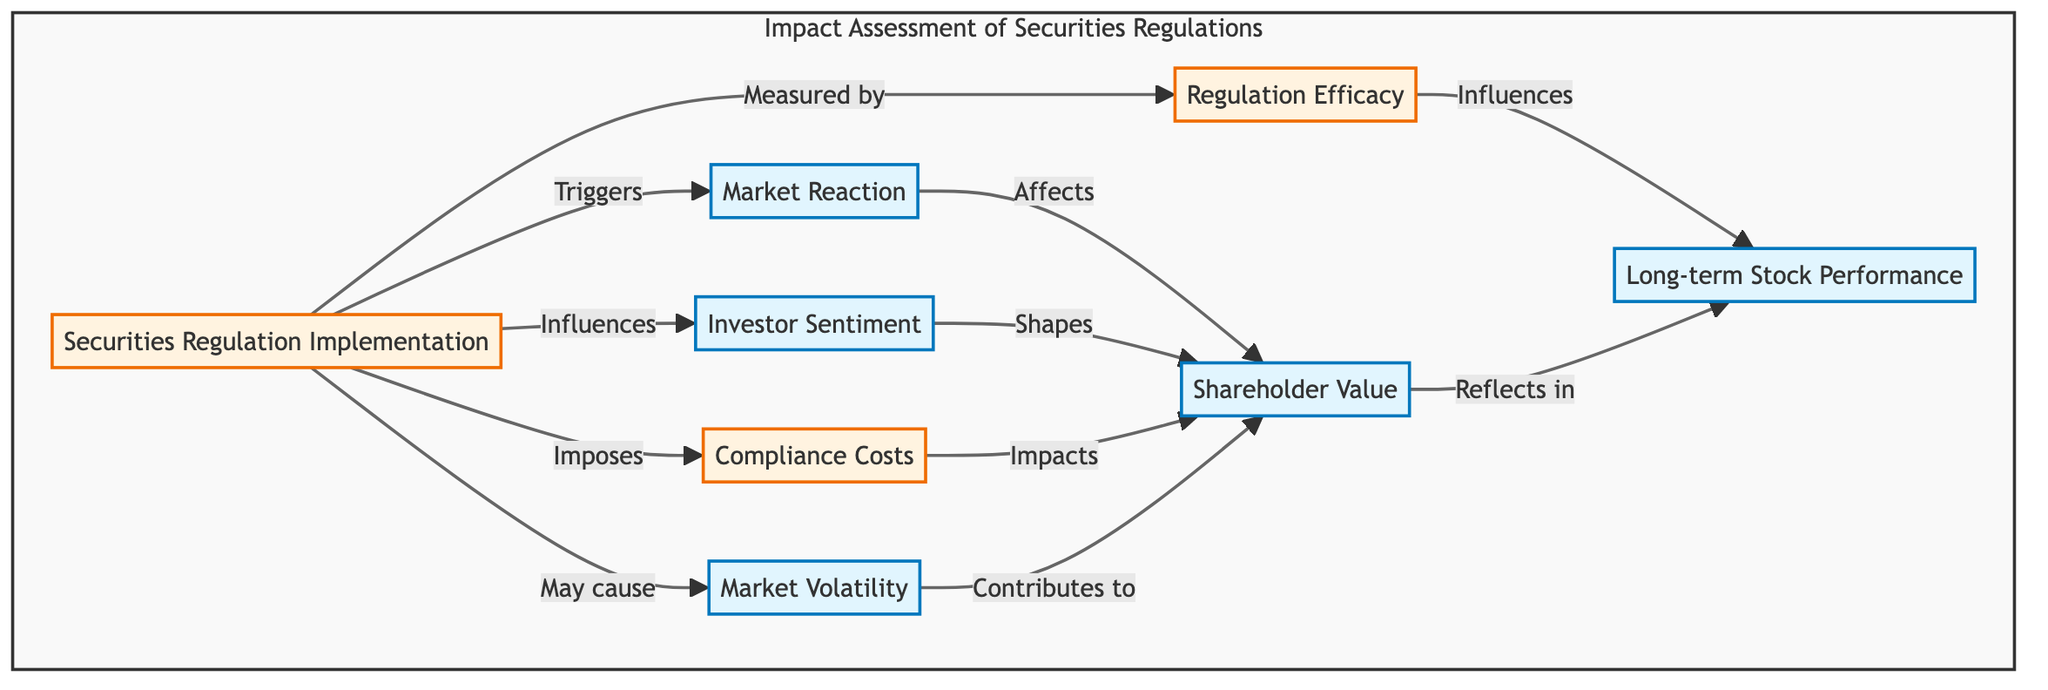What is the first step in the flow chart? The first step is "Securities Regulation Implementation," which initiates the process of assessing the impact of regulations on company stock prices.
Answer: Securities Regulation Implementation How many main elements are in this diagram? There are eight main elements detailing the impact assessment flow regarding securities regulations and their effects on stock prices.
Answer: Eight Which node is directly influenced by "Market Reaction"? "Shareholder Value" is directly influenced by "Market Reaction," indicating that initial stock price changes after regulation affect long-term shareholder value.
Answer: Shareholder Value What does "Investor Sentiment" primarily influence? "Investor Sentiment" primarily influences "Shareholder Value" by affecting how investors perceive the company's risk and compliance in response to regulations.
Answer: Shareholder Value Which element is assessed for effectiveness in the flow chart? "Regulation Efficacy" is assessed for its effectiveness in preventing market abuses, indicating that not only investor reactions are measured but also the regulations' performance.
Answer: Regulation Efficacy What relationship does "Compliance Costs" have with "Shareholder Value"? "Compliance Costs" has an impact on "Shareholder Value," which suggests that the financial burden of regulatory compliance may negatively affect the value returned to shareholders.
Answer: Impacts How do "Market Volatility" and "Shareholder Value" relate to each other? "Market Volatility" contributes to "Shareholder Value," indicating that fluctuations in market conditions following regulation influence long-term stock performance.
Answer: Contributes to What follows the "Securities Regulation Implementation"? "Market Reaction" and "Investor Sentiment" follow the "Securities Regulation Implementation," indicating the immediate effects and perceptions influenced by the new regulations.
Answer: Market Reaction, Investor Sentiment Which node reflects long-term stock performance? "Long-term Stock Performance" reflects the trends in stock price over time after regulatory changes, capturing the overall impact of the regulations on the company's value.
Answer: Long-term Stock Performance 